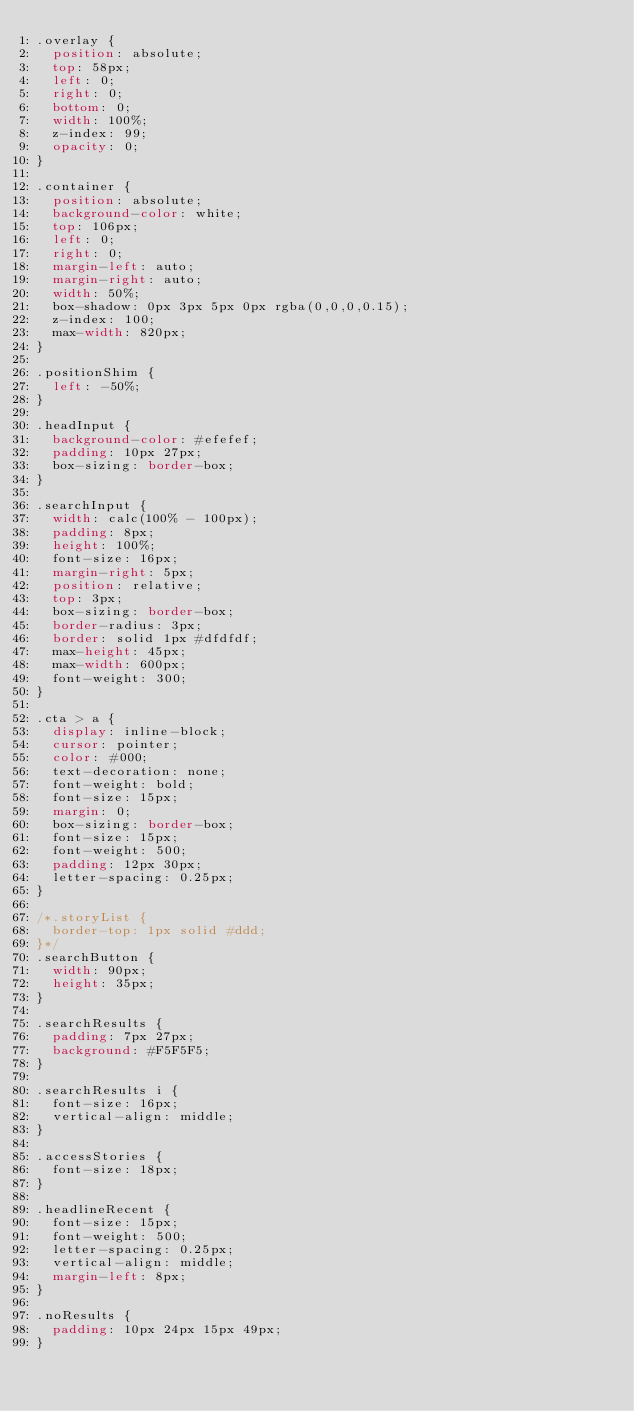<code> <loc_0><loc_0><loc_500><loc_500><_CSS_>.overlay {
  position: absolute;
  top: 58px;
  left: 0;
  right: 0;
  bottom: 0;
  width: 100%;
  z-index: 99;
  opacity: 0;
}

.container {
  position: absolute;
  background-color: white;
  top: 106px;
  left: 0;
  right: 0;
  margin-left: auto;
  margin-right: auto;
  width: 50%;
  box-shadow: 0px 3px 5px 0px rgba(0,0,0,0.15);
  z-index: 100;
  max-width: 820px;
}

.positionShim {
  left: -50%;
}

.headInput {
  background-color: #efefef;
  padding: 10px 27px;
  box-sizing: border-box;
}

.searchInput {
  width: calc(100% - 100px);
  padding: 8px;
  height: 100%;
  font-size: 16px;
  margin-right: 5px;
  position: relative;
  top: 3px;
  box-sizing: border-box;
  border-radius: 3px;
  border: solid 1px #dfdfdf;
  max-height: 45px;
  max-width: 600px;
  font-weight: 300;
}

.cta > a {
  display: inline-block;
  cursor: pointer;
  color: #000;
  text-decoration: none;
  font-weight: bold;
  font-size: 15px;
  margin: 0;
  box-sizing: border-box;
  font-size: 15px;
  font-weight: 500;
  padding: 12px 30px;
  letter-spacing: 0.25px;
}

/*.storyList {
  border-top: 1px solid #ddd;
}*/
.searchButton {
  width: 90px;
  height: 35px;
}

.searchResults {
  padding: 7px 27px;
  background: #F5F5F5;
}

.searchResults i {
  font-size: 16px;
  vertical-align: middle;
}

.accessStories {
  font-size: 18px;
}

.headlineRecent {
  font-size: 15px;
  font-weight: 500;
  letter-spacing: 0.25px;
  vertical-align: middle;
  margin-left: 8px;
}

.noResults {
  padding: 10px 24px 15px 49px;
}
</code> 